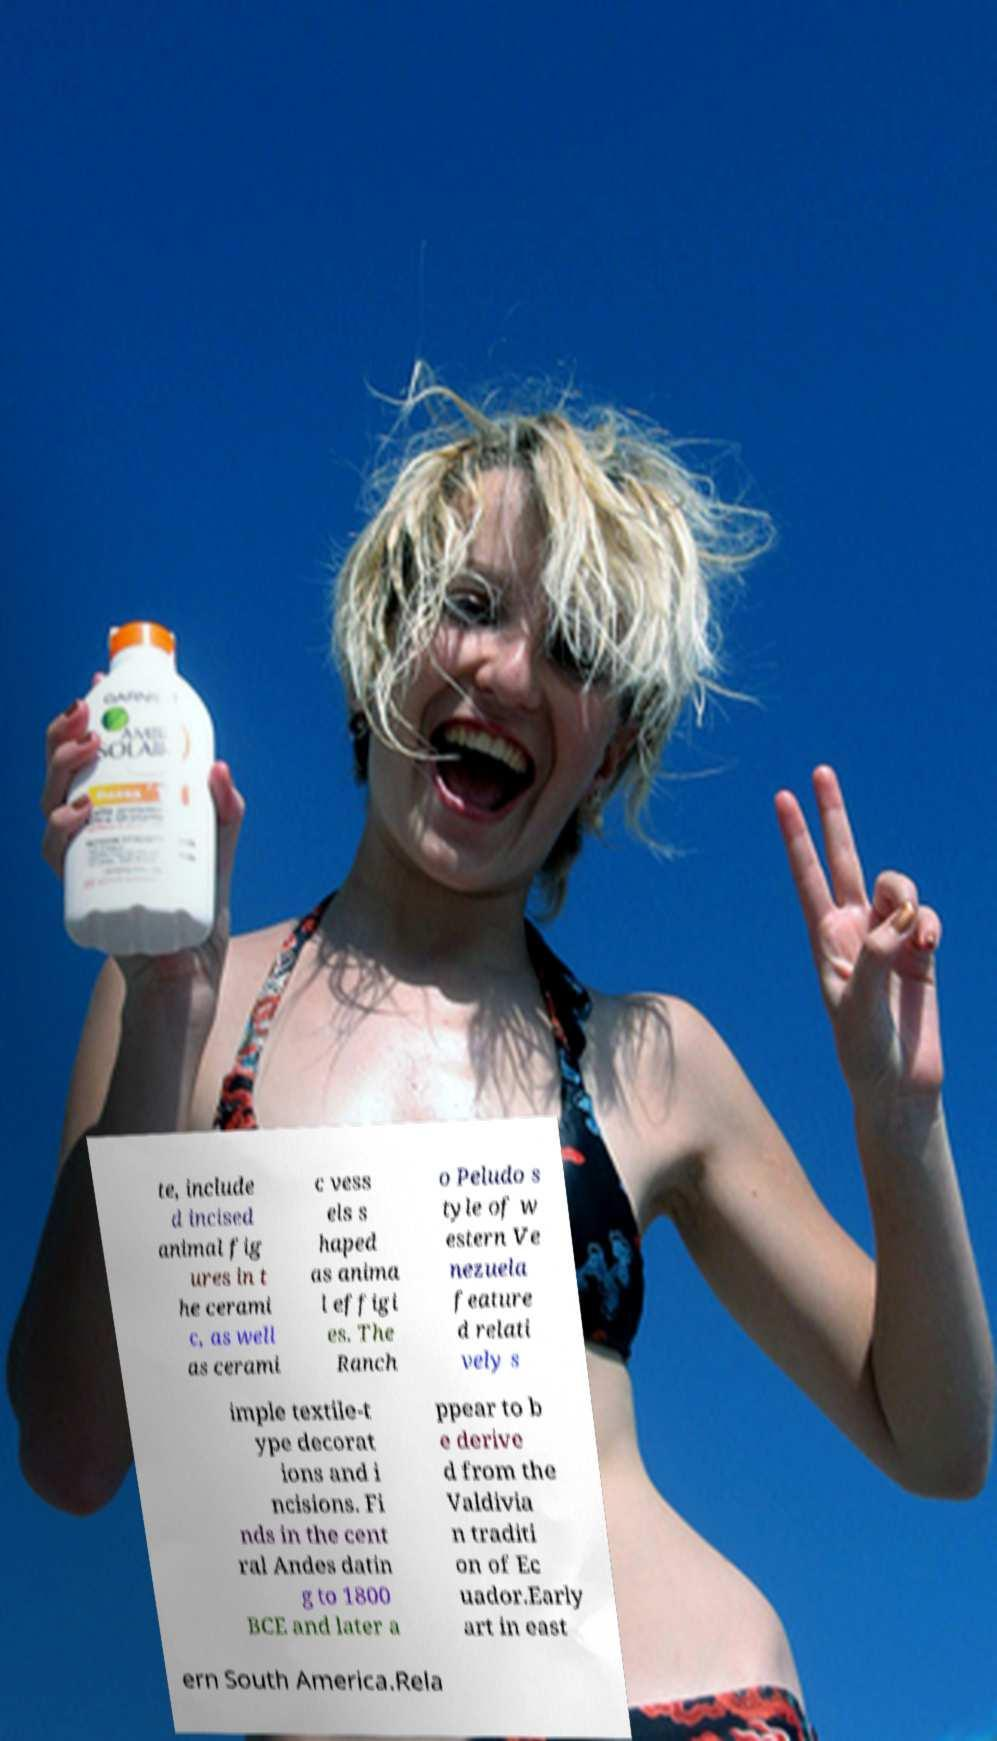What messages or text are displayed in this image? I need them in a readable, typed format. te, include d incised animal fig ures in t he cerami c, as well as cerami c vess els s haped as anima l effigi es. The Ranch o Peludo s tyle of w estern Ve nezuela feature d relati vely s imple textile-t ype decorat ions and i ncisions. Fi nds in the cent ral Andes datin g to 1800 BCE and later a ppear to b e derive d from the Valdivia n traditi on of Ec uador.Early art in east ern South America.Rela 